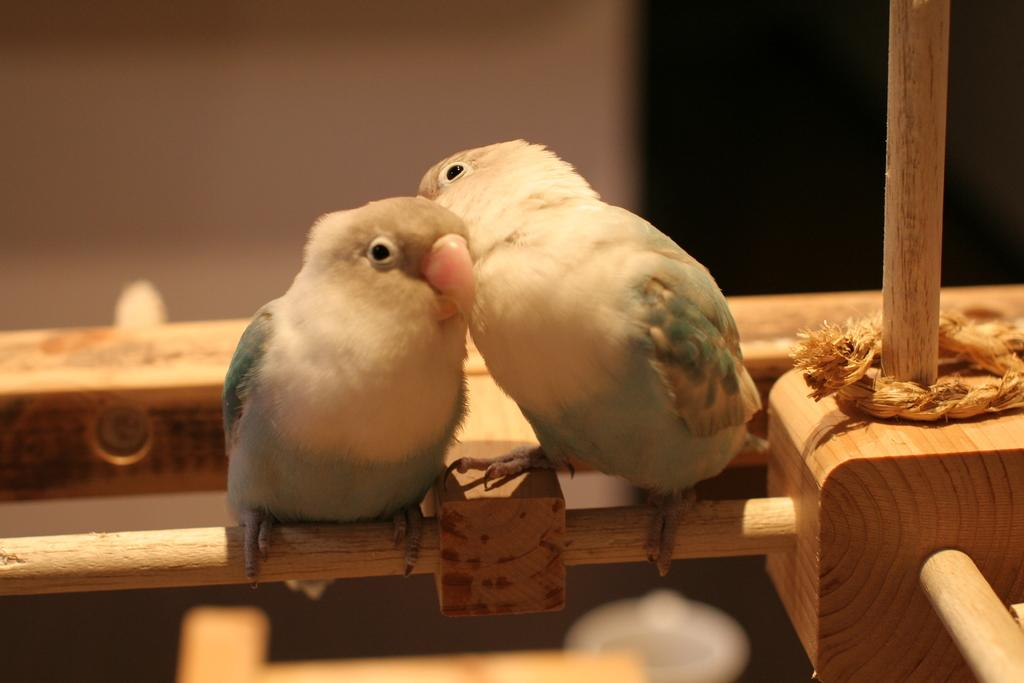How many birds are visible in the image? There are two birds in the image. What are the birds perched on? The birds are on a wooden object. What can be seen on the right side of the image? There is a rope on the right side of the image. What type of lamp is hanging from the wooden object in the image? There is no lamp present in the image; it features two birds on a wooden object and a rope on the right side. 